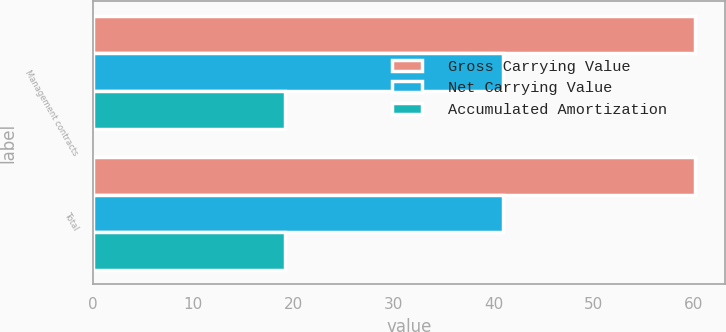Convert chart to OTSL. <chart><loc_0><loc_0><loc_500><loc_500><stacked_bar_chart><ecel><fcel>Management contracts<fcel>Total<nl><fcel>Gross Carrying Value<fcel>60.1<fcel>60.1<nl><fcel>Net Carrying Value<fcel>40.9<fcel>40.9<nl><fcel>Accumulated Amortization<fcel>19.2<fcel>19.2<nl></chart> 